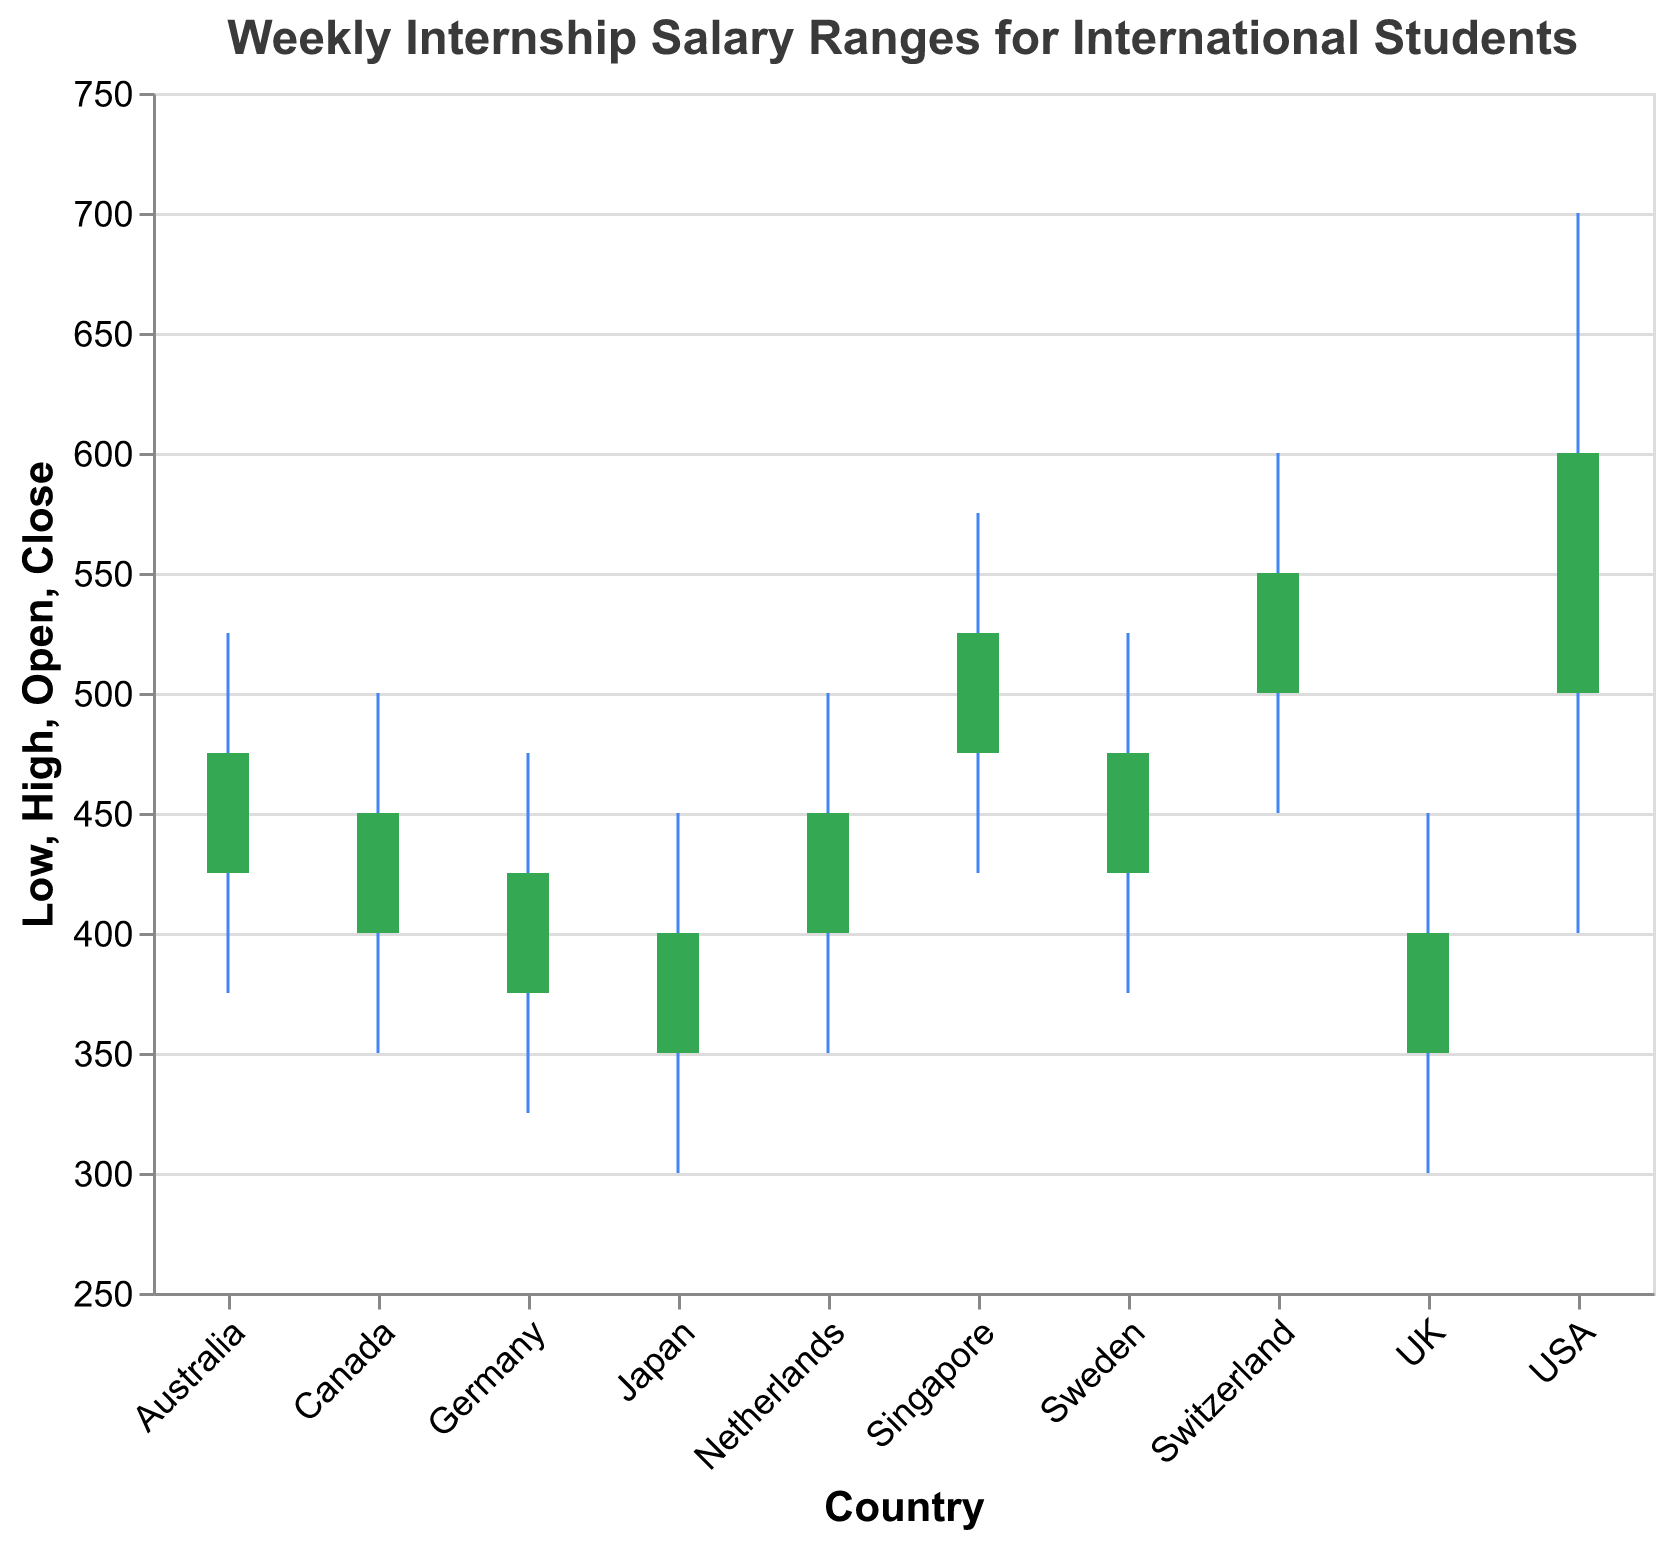What is the highest weekly internship salary in Switzerland? According to the chart, the highest salary value for Switzerland is represented by the upper tip of the vertical rule bar. It reaches a value of 600.
Answer: 600 What is the range of weekly internship salaries in Australia? The range can be calculated by subtracting the lowest salary from the highest salary value for Australia. The chart shows the lowest value is 375 and the highest value is 525. So, the range is 525 - 375 = 150.
Answer: 150 Which country has the lowest opening salary? To find the lowest opening salary, look at the bar beginning values for each country. The lowest starting salary is 350, which is present in both the UK and Japan.
Answer: UK and Japan What is the difference between the lowest salary in Germany and Singapore? The lowest salary values for Germany and Singapore are shown as 325 and 425 respectively. The difference can be calculated as 425 - 325 = 100.
Answer: 100 Which country has the highest closing salary, and what is it? To determine the highest closing salary, check the upper border of the filled bar for each country. The highest closing salary is 600, which is in the USA.
Answer: USA, 600 What is the average high salary across all countries? Add all high salaries and divide by the number of countries: (700 + 450 + 500 + 525 + 475 + 450 + 575 + 600 + 500 + 525) / 10 = 5300 / 10 = 530.
Answer: 530 Which country has the smallest salary range, and what is the range? To find the country with the smallest range, subtract each country's low salary from its high salary and compare: USA (300), UK (150), Canada (150), Australia (150), Germany (150), Japan (150), Singapore (150), Switzerland (150), Netherlands (150), Sweden (150). The smallest range is in the UK, Canada, Australia, Germany, Japan, Singapore, Netherlands, and Sweden, all at 150.
Answer: UK, Canada, Australia, Germany, Japan, Singapore, Netherlands, Sweden, 150 